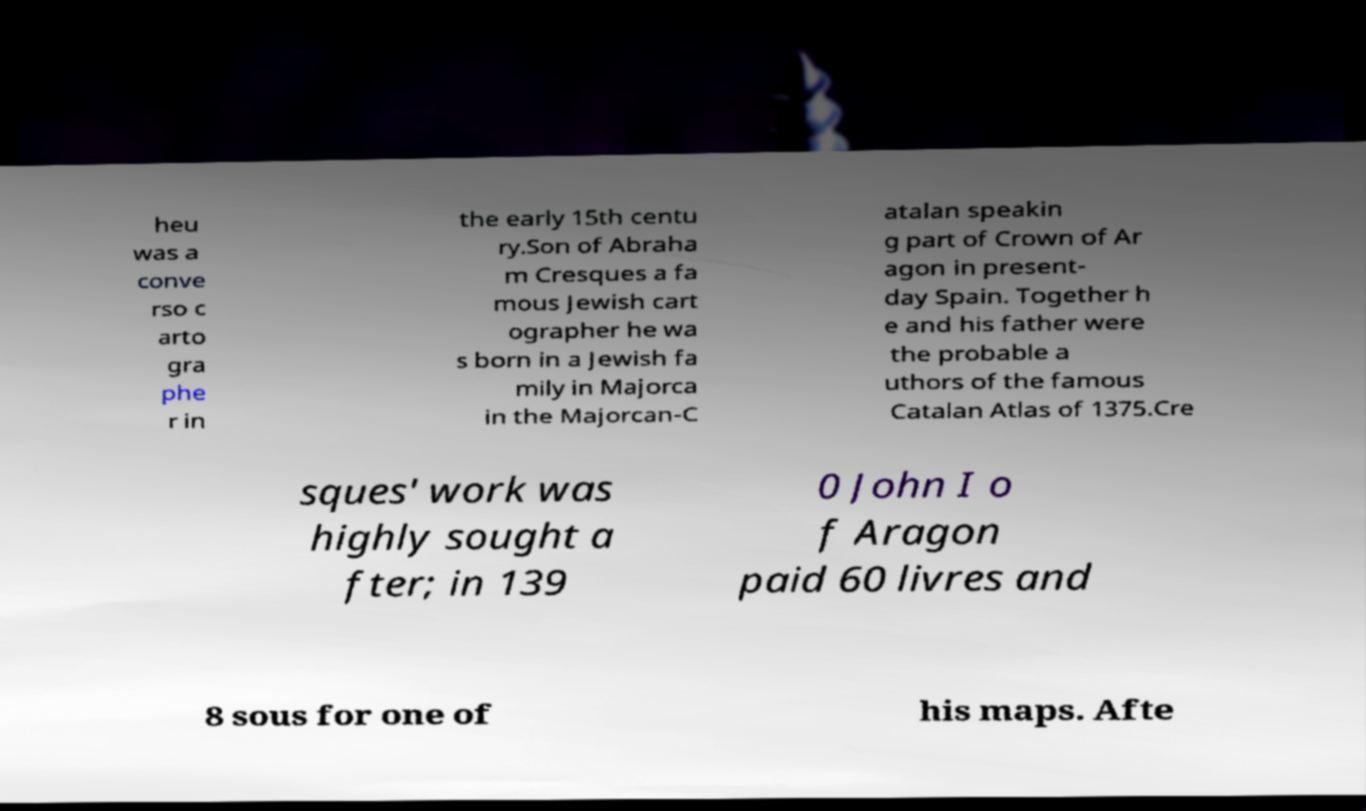Can you read and provide the text displayed in the image?This photo seems to have some interesting text. Can you extract and type it out for me? heu was a conve rso c arto gra phe r in the early 15th centu ry.Son of Abraha m Cresques a fa mous Jewish cart ographer he wa s born in a Jewish fa mily in Majorca in the Majorcan-C atalan speakin g part of Crown of Ar agon in present- day Spain. Together h e and his father were the probable a uthors of the famous Catalan Atlas of 1375.Cre sques' work was highly sought a fter; in 139 0 John I o f Aragon paid 60 livres and 8 sous for one of his maps. Afte 